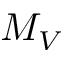<formula> <loc_0><loc_0><loc_500><loc_500>M _ { V }</formula> 